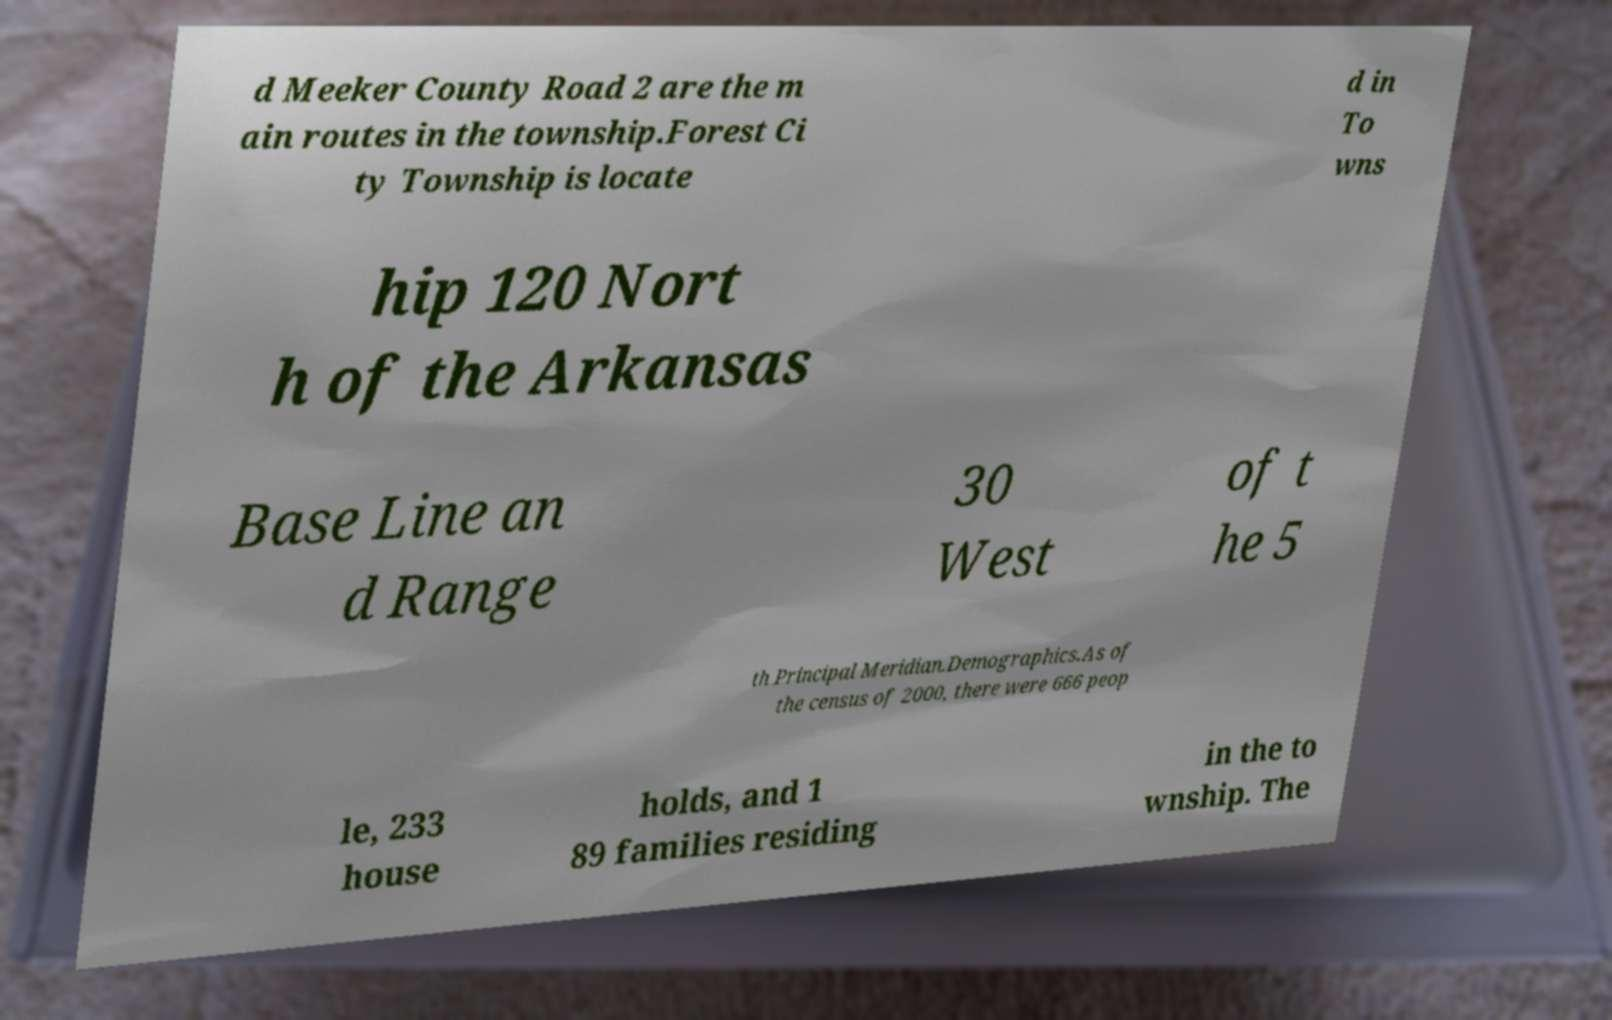Please read and relay the text visible in this image. What does it say? d Meeker County Road 2 are the m ain routes in the township.Forest Ci ty Township is locate d in To wns hip 120 Nort h of the Arkansas Base Line an d Range 30 West of t he 5 th Principal Meridian.Demographics.As of the census of 2000, there were 666 peop le, 233 house holds, and 1 89 families residing in the to wnship. The 